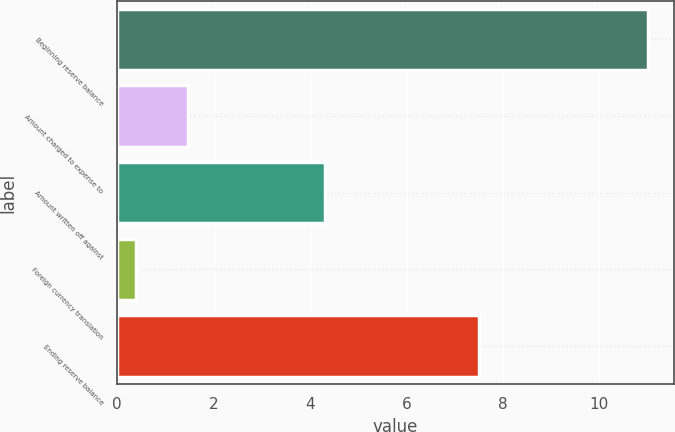Convert chart to OTSL. <chart><loc_0><loc_0><loc_500><loc_500><bar_chart><fcel>Beginning reserve balance<fcel>Amount charged to expense to<fcel>Amount written off against<fcel>Foreign currency translation<fcel>Ending reserve balance<nl><fcel>11<fcel>1.46<fcel>4.3<fcel>0.4<fcel>7.5<nl></chart> 